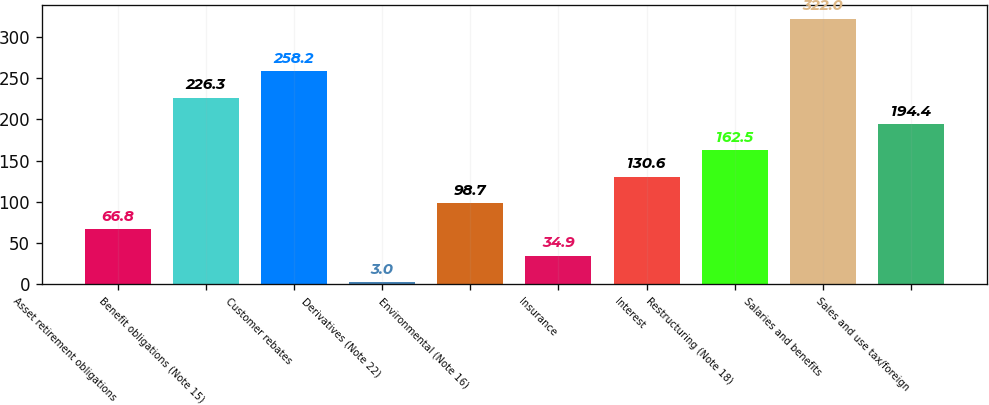Convert chart. <chart><loc_0><loc_0><loc_500><loc_500><bar_chart><fcel>Asset retirement obligations<fcel>Benefit obligations (Note 15)<fcel>Customer rebates<fcel>Derivatives (Note 22)<fcel>Environmental (Note 16)<fcel>Insurance<fcel>Interest<fcel>Restructuring (Note 18)<fcel>Salaries and benefits<fcel>Sales and use tax/foreign<nl><fcel>66.8<fcel>226.3<fcel>258.2<fcel>3<fcel>98.7<fcel>34.9<fcel>130.6<fcel>162.5<fcel>322<fcel>194.4<nl></chart> 